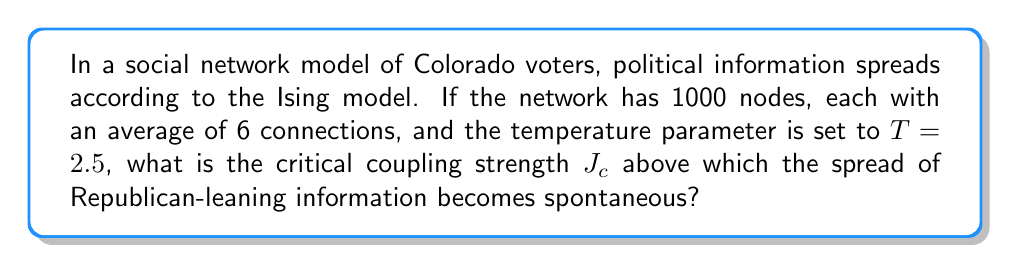Provide a solution to this math problem. To solve this problem, we'll use principles from statistical mechanics, specifically the Ising model applied to social networks:

1) In the Ising model, the critical temperature for a network is given by:

   $$T_c = \frac{2J_c}{\ln(k+1)}$$

   where $k$ is the average number of connections per node.

2) We're given $T = 2.5$ and $k = 6$. We need to find $J_c$.

3) Rearranging the equation:

   $$J_c = \frac{T_c \ln(k+1)}{2}$$

4) Substituting our known values:

   $$J_c = \frac{2.5 \ln(6+1)}{2}$$

5) Simplify:
   
   $$J_c = \frac{2.5 \ln(7)}{2}$$

6) Calculate:

   $$J_c \approx 1.2413$$

This value represents the critical coupling strength above which Republican-leaning information would spread spontaneously through the network.
Answer: $J_c \approx 1.2413$ 